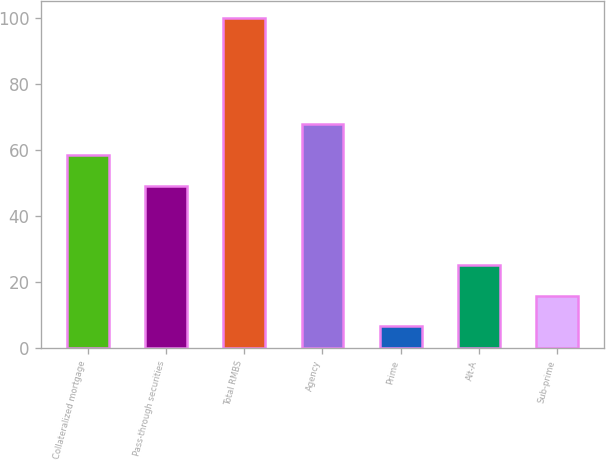Convert chart to OTSL. <chart><loc_0><loc_0><loc_500><loc_500><bar_chart><fcel>Collateralized mortgage<fcel>Pass-through securities<fcel>Total RMBS<fcel>Agency<fcel>Prime<fcel>Alt-A<fcel>Sub-prime<nl><fcel>58.44<fcel>49.1<fcel>100<fcel>67.78<fcel>6.6<fcel>25.28<fcel>15.94<nl></chart> 